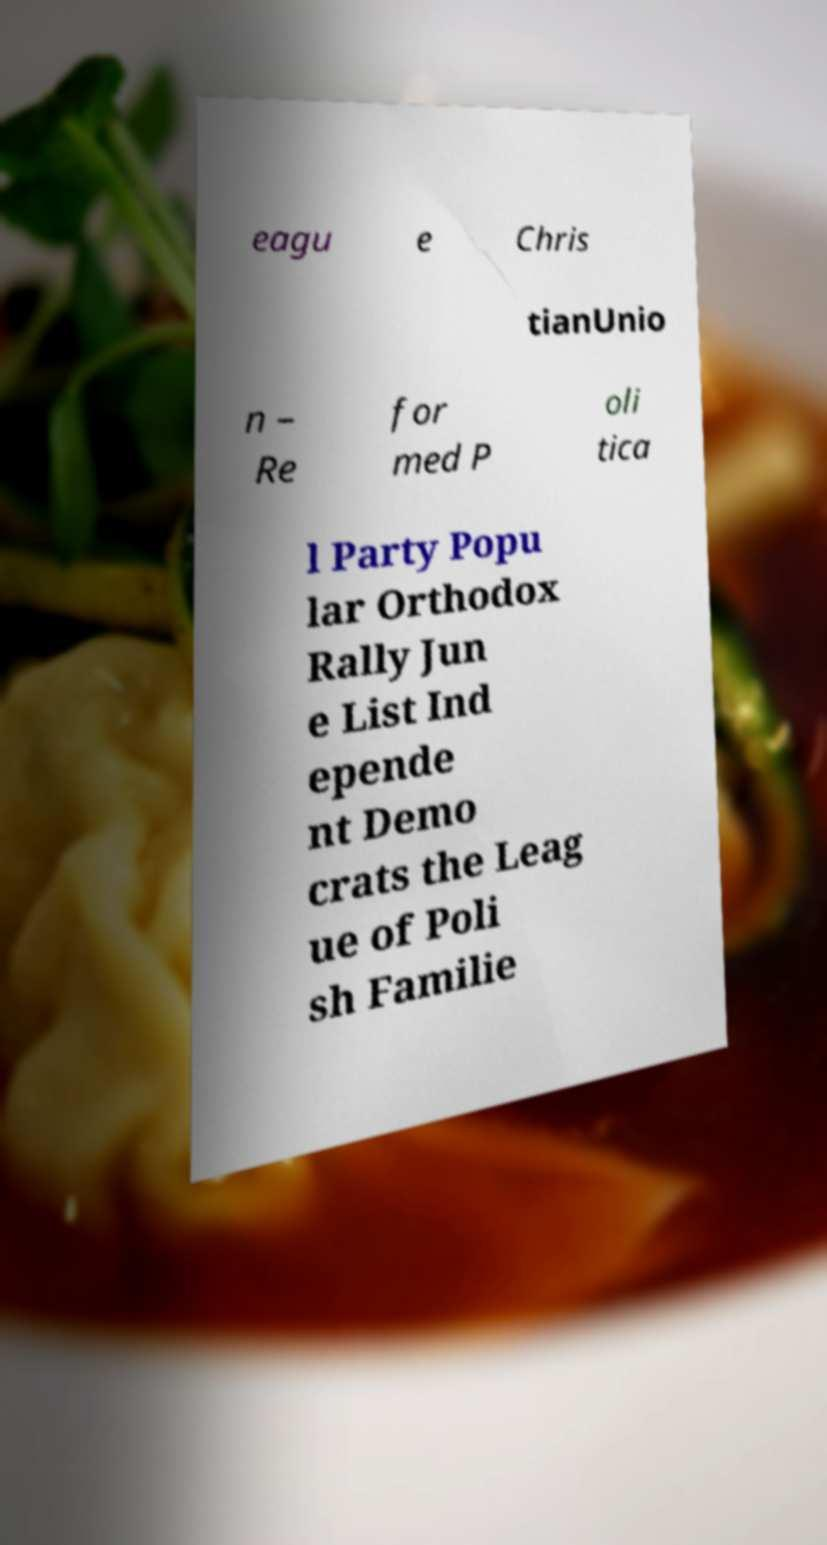Could you extract and type out the text from this image? eagu e Chris tianUnio n – Re for med P oli tica l Party Popu lar Orthodox Rally Jun e List Ind epende nt Demo crats the Leag ue of Poli sh Familie 